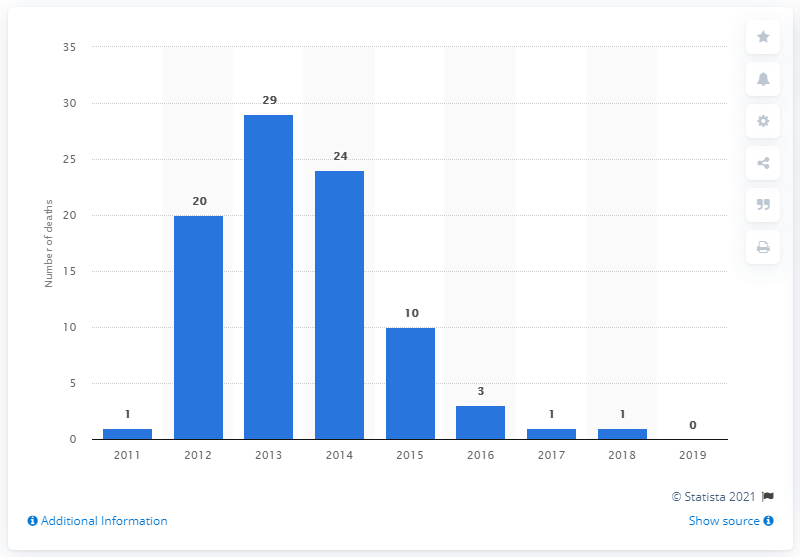Give some essential details in this illustration. The highest number of PMA/PMMA-related deaths in 2013 was 29. 